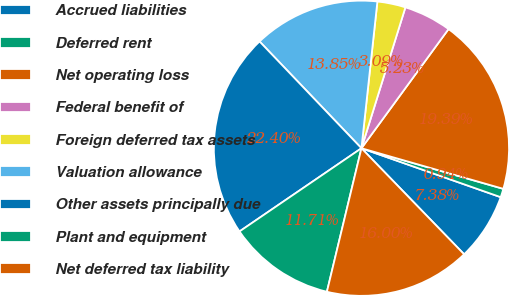<chart> <loc_0><loc_0><loc_500><loc_500><pie_chart><fcel>Accrued liabilities<fcel>Deferred rent<fcel>Net operating loss<fcel>Federal benefit of<fcel>Foreign deferred tax assets<fcel>Valuation allowance<fcel>Other assets principally due<fcel>Plant and equipment<fcel>Net deferred tax liability<nl><fcel>7.38%<fcel>0.94%<fcel>19.39%<fcel>5.23%<fcel>3.09%<fcel>13.85%<fcel>22.4%<fcel>11.71%<fcel>16.0%<nl></chart> 